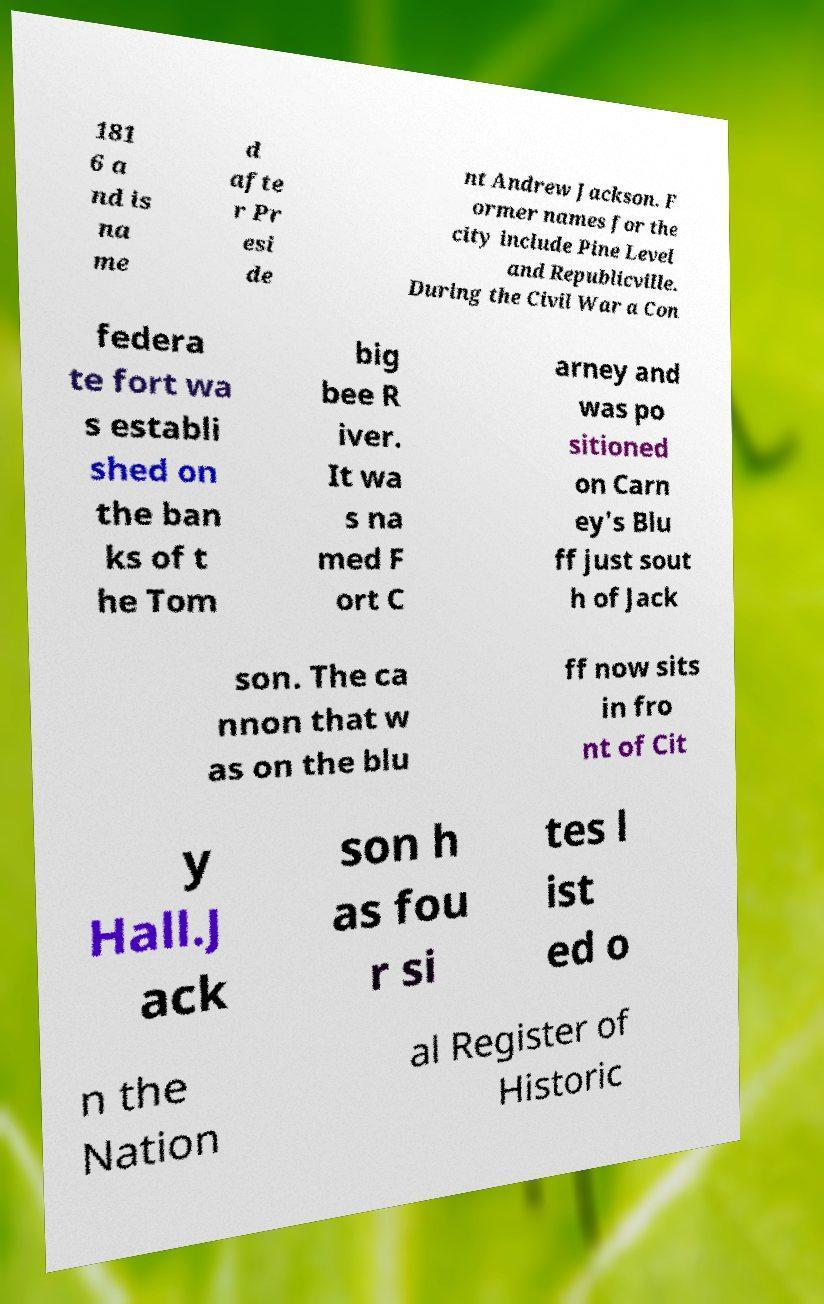Please identify and transcribe the text found in this image. 181 6 a nd is na me d afte r Pr esi de nt Andrew Jackson. F ormer names for the city include Pine Level and Republicville. During the Civil War a Con federa te fort wa s establi shed on the ban ks of t he Tom big bee R iver. It wa s na med F ort C arney and was po sitioned on Carn ey's Blu ff just sout h of Jack son. The ca nnon that w as on the blu ff now sits in fro nt of Cit y Hall.J ack son h as fou r si tes l ist ed o n the Nation al Register of Historic 